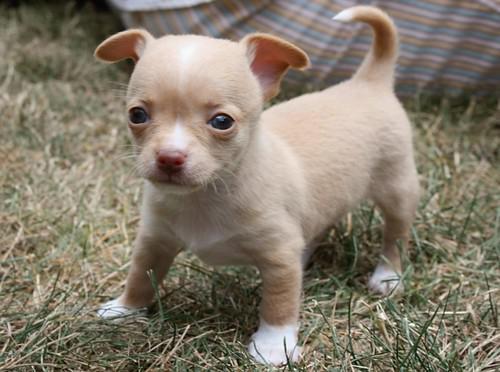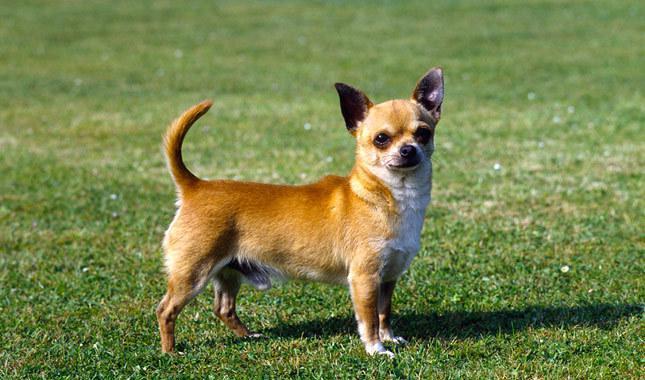The first image is the image on the left, the second image is the image on the right. Assess this claim about the two images: "At least one dog is sitting.". Correct or not? Answer yes or no. No. 